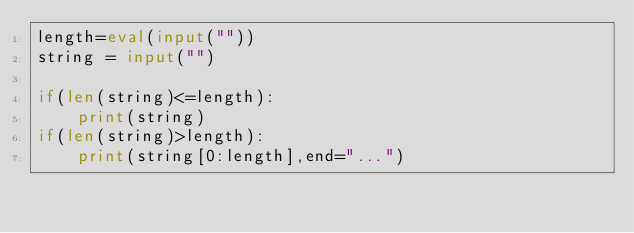<code> <loc_0><loc_0><loc_500><loc_500><_Python_>length=eval(input(""))
string = input("")

if(len(string)<=length):
    print(string)
if(len(string)>length):
    print(string[0:length],end="...")</code> 